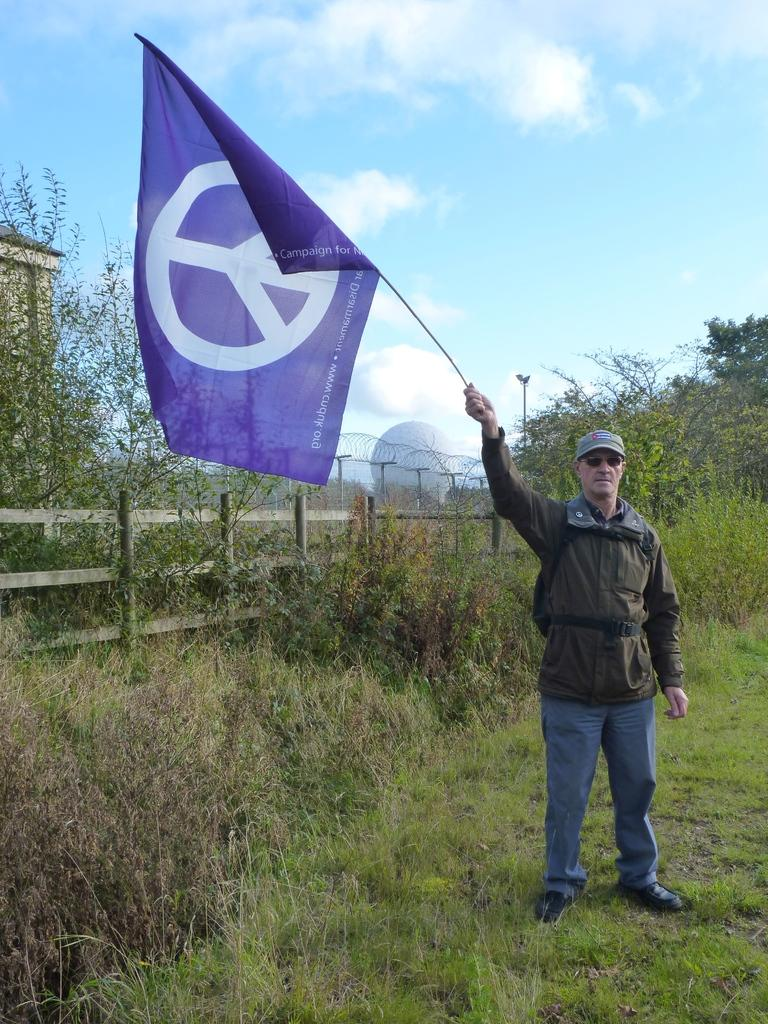What is the primary feature of the land in the image? The land is covered with grass. What is the person in the image doing? The person is standing and holding a flag. What can be seen in the background of the image? There are plants, a fence, and trees in the background. How would you describe the sky in the image? The sky is cloudy in the image. What book is the person reading while holding the flag in the image? There is no book present in the image; the person is only holding a flag. What type of relation does the person have with the plants in the background? There is no indication of a relation between the person and the plants in the image. 